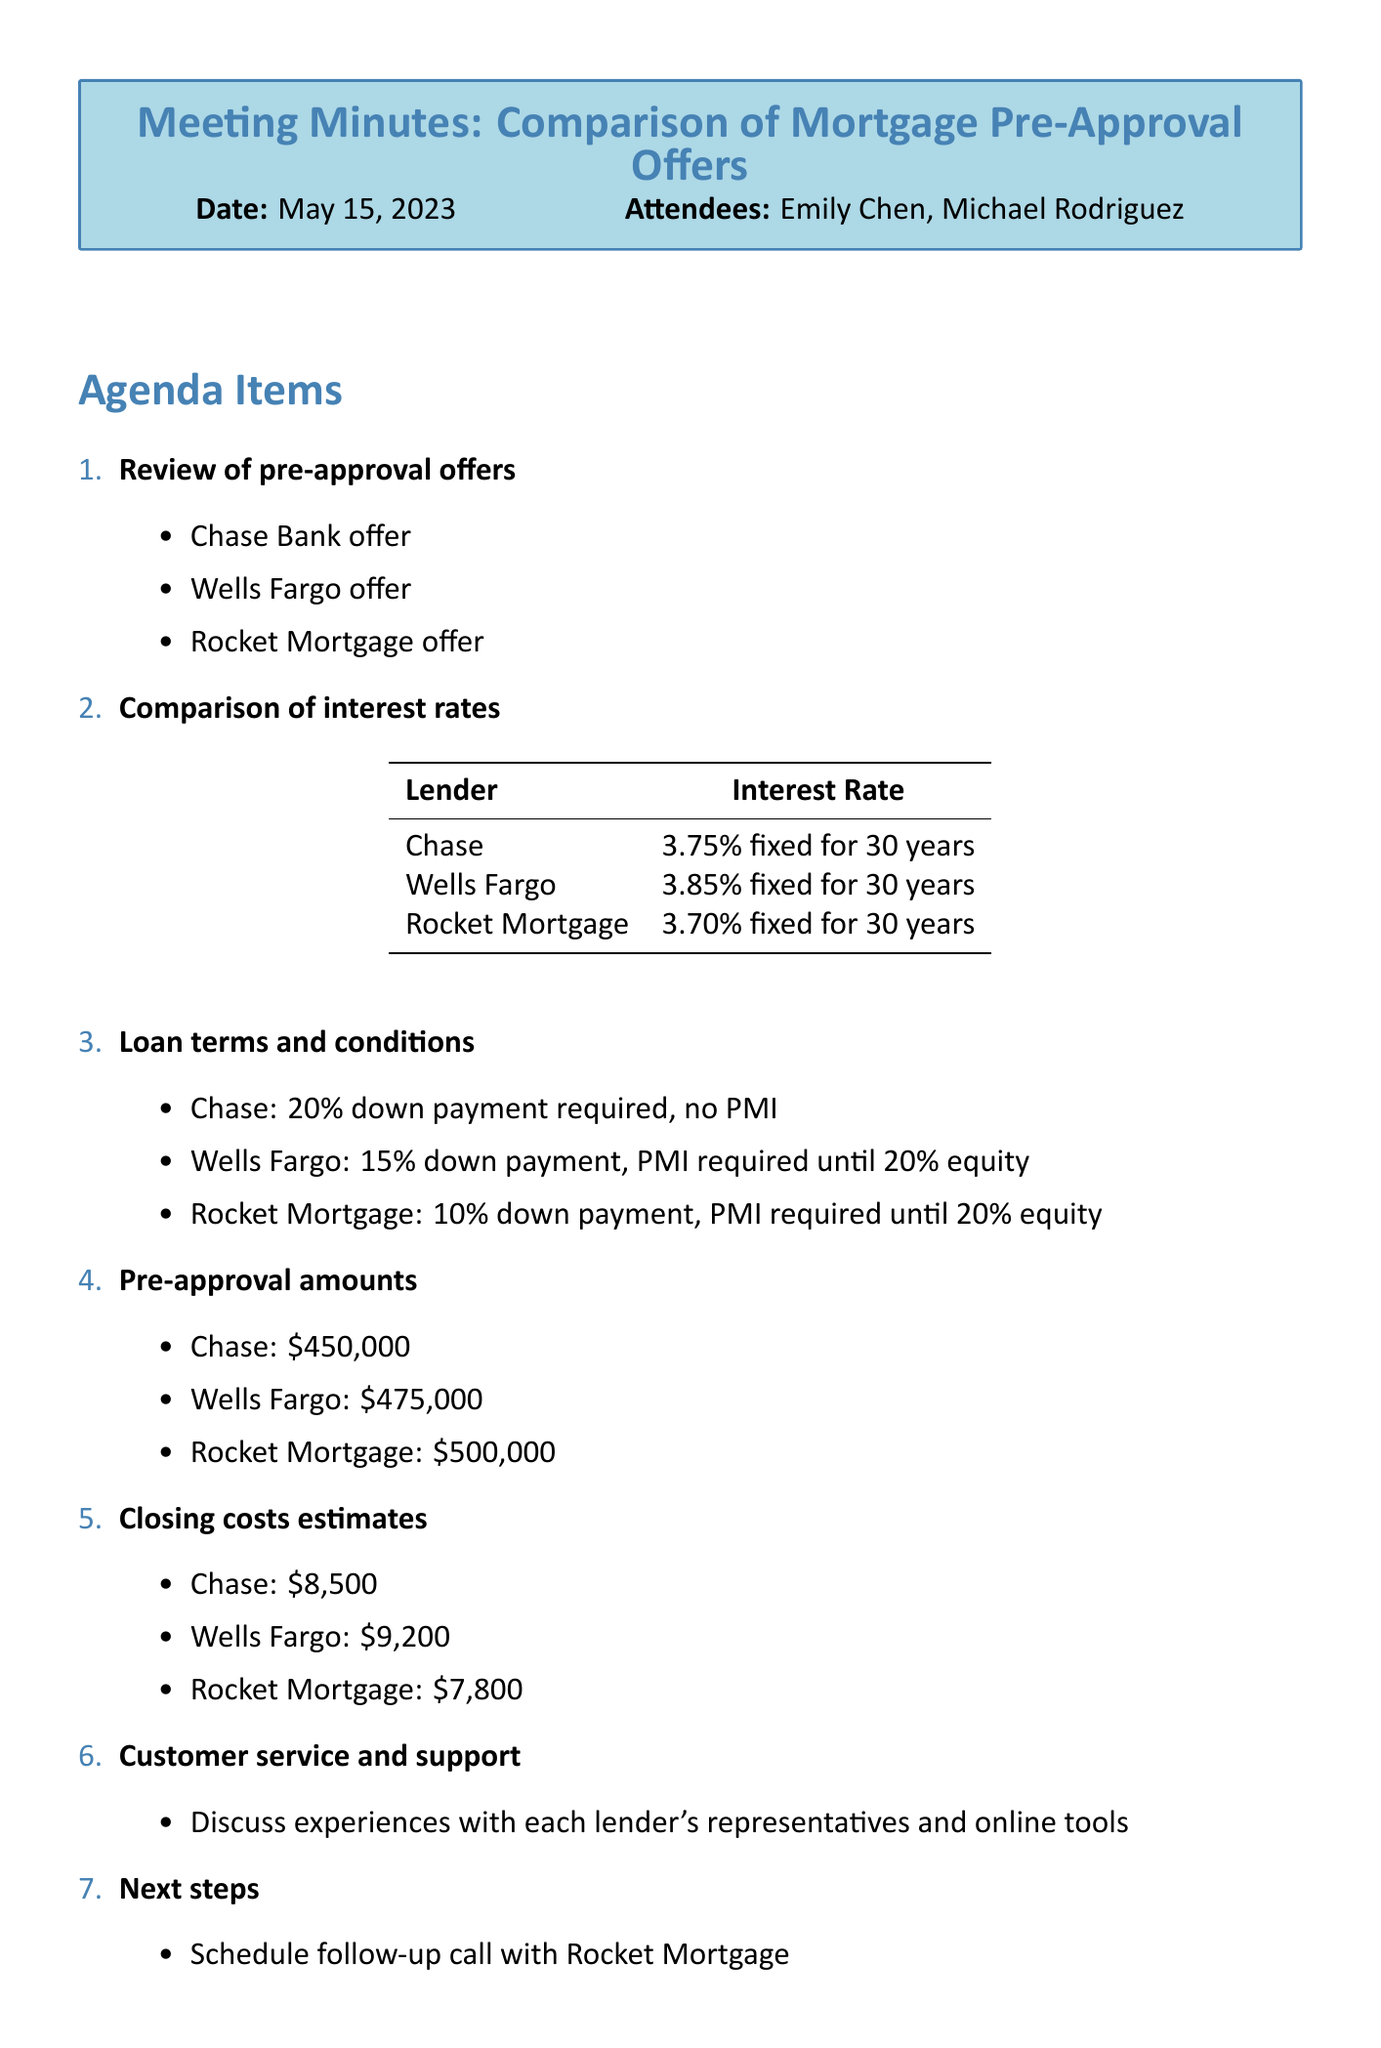What is the interest rate offered by Rocket Mortgage? The document specifies that Rocket Mortgage offers a 3.70% fixed interest rate for 30 years.
Answer: 3.70% What is the pre-approval amount from Wells Fargo? According to the document, Wells Fargo offers a pre-approval amount of $475,000.
Answer: $475,000 What is the required down payment for Chase Bank? The document states that Chase Bank requires a 20% down payment with no PMI.
Answer: 20% Which lender has the lowest closing costs? The document indicates that Rocket Mortgage has the lowest closing costs estimated at $7,800.
Answer: Rocket Mortgage How many attendees were present at the meeting? The document mentions that there were two attendees, Emily Chen and Michael Rodriguez.
Answer: 2 What is one of the next steps from the meeting? One of the action items discussed was to request a detailed fee breakdown from all lenders.
Answer: Request detailed fee breakdown from all lenders Which lender requires PMI until 20% equity is reached? The document lists that both Wells Fargo and Rocket Mortgage require PMI until 20% equity is reached.
Answer: Wells Fargo, Rocket Mortgage What date was the meeting held? The document clearly states that the meeting took place on May 15, 2023.
Answer: May 15, 2023 